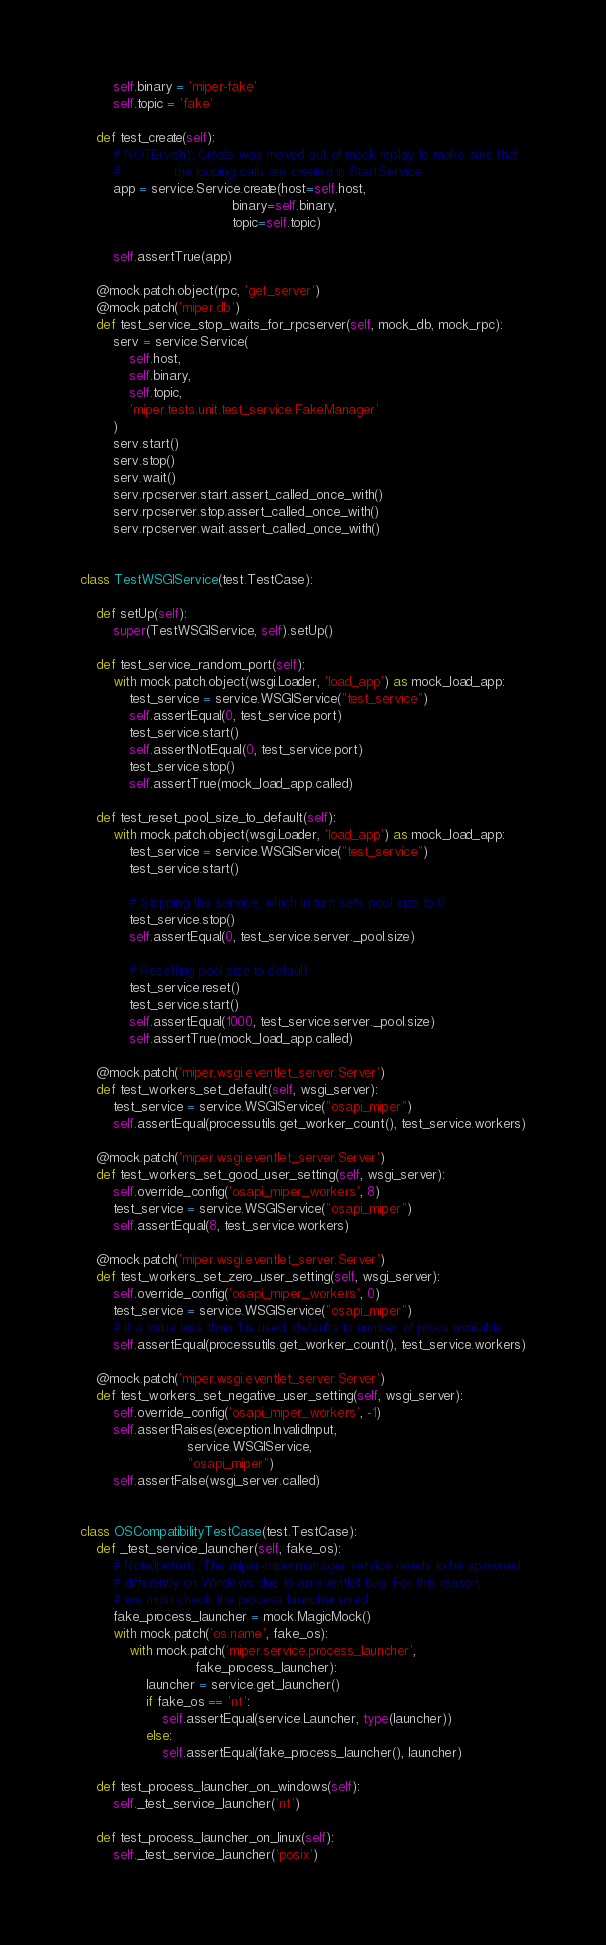<code> <loc_0><loc_0><loc_500><loc_500><_Python_>        self.binary = 'miper-fake'
        self.topic = 'fake'

    def test_create(self):
        # NOTE(vish): Create was moved out of mock replay to make sure that
        #             the looping calls are created in StartService.
        app = service.Service.create(host=self.host,
                                     binary=self.binary,
                                     topic=self.topic)

        self.assertTrue(app)

    @mock.patch.object(rpc, 'get_server')
    @mock.patch('miper.db')
    def test_service_stop_waits_for_rpcserver(self, mock_db, mock_rpc):
        serv = service.Service(
            self.host,
            self.binary,
            self.topic,
            'miper.tests.unit.test_service.FakeManager'
        )
        serv.start()
        serv.stop()
        serv.wait()
        serv.rpcserver.start.assert_called_once_with()
        serv.rpcserver.stop.assert_called_once_with()
        serv.rpcserver.wait.assert_called_once_with()


class TestWSGIService(test.TestCase):

    def setUp(self):
        super(TestWSGIService, self).setUp()

    def test_service_random_port(self):
        with mock.patch.object(wsgi.Loader, 'load_app') as mock_load_app:
            test_service = service.WSGIService("test_service")
            self.assertEqual(0, test_service.port)
            test_service.start()
            self.assertNotEqual(0, test_service.port)
            test_service.stop()
            self.assertTrue(mock_load_app.called)

    def test_reset_pool_size_to_default(self):
        with mock.patch.object(wsgi.Loader, 'load_app') as mock_load_app:
            test_service = service.WSGIService("test_service")
            test_service.start()

            # Stopping the service, which in turn sets pool size to 0
            test_service.stop()
            self.assertEqual(0, test_service.server._pool.size)

            # Resetting pool size to default
            test_service.reset()
            test_service.start()
            self.assertEqual(1000, test_service.server._pool.size)
            self.assertTrue(mock_load_app.called)

    @mock.patch('miper.wsgi.eventlet_server.Server')
    def test_workers_set_default(self, wsgi_server):
        test_service = service.WSGIService("osapi_miper")
        self.assertEqual(processutils.get_worker_count(), test_service.workers)

    @mock.patch('miper.wsgi.eventlet_server.Server')
    def test_workers_set_good_user_setting(self, wsgi_server):
        self.override_config('osapi_miper_workers', 8)
        test_service = service.WSGIService("osapi_miper")
        self.assertEqual(8, test_service.workers)

    @mock.patch('miper.wsgi.eventlet_server.Server')
    def test_workers_set_zero_user_setting(self, wsgi_server):
        self.override_config('osapi_miper_workers', 0)
        test_service = service.WSGIService("osapi_miper")
        # If a value less than 1 is used, defaults to number of procs available
        self.assertEqual(processutils.get_worker_count(), test_service.workers)

    @mock.patch('miper.wsgi.eventlet_server.Server')
    def test_workers_set_negative_user_setting(self, wsgi_server):
        self.override_config('osapi_miper_workers', -1)
        self.assertRaises(exception.InvalidInput,
                          service.WSGIService,
                          "osapi_miper")
        self.assertFalse(wsgi_server.called)


class OSCompatibilityTestCase(test.TestCase):
    def _test_service_launcher(self, fake_os):
        # Note(lpetrut): The miper-mipermanager service needs to be spawned
        # differently on Windows due to an eventlet bug. For this reason,
        # we must check the process launcher used.
        fake_process_launcher = mock.MagicMock()
        with mock.patch('os.name', fake_os):
            with mock.patch('miper.service.process_launcher',
                            fake_process_launcher):
                launcher = service.get_launcher()
                if fake_os == 'nt':
                    self.assertEqual(service.Launcher, type(launcher))
                else:
                    self.assertEqual(fake_process_launcher(), launcher)

    def test_process_launcher_on_windows(self):
        self._test_service_launcher('nt')

    def test_process_launcher_on_linux(self):
        self._test_service_launcher('posix')
</code> 